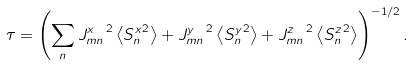Convert formula to latex. <formula><loc_0><loc_0><loc_500><loc_500>\tau = \left ( \sum _ { n } { J ^ { x } _ { m n } } ^ { \, 2 } \left \langle { S _ { n } ^ { x } } ^ { 2 } \right \rangle + { J ^ { y } _ { m n } } ^ { \, 2 } \left \langle { S _ { n } ^ { y } } ^ { 2 } \right \rangle + { J ^ { z } _ { m n } } ^ { \, 2 } \left \langle { S _ { n } ^ { z } } ^ { 2 } \right \rangle \right ) ^ { - 1 / 2 } .</formula> 